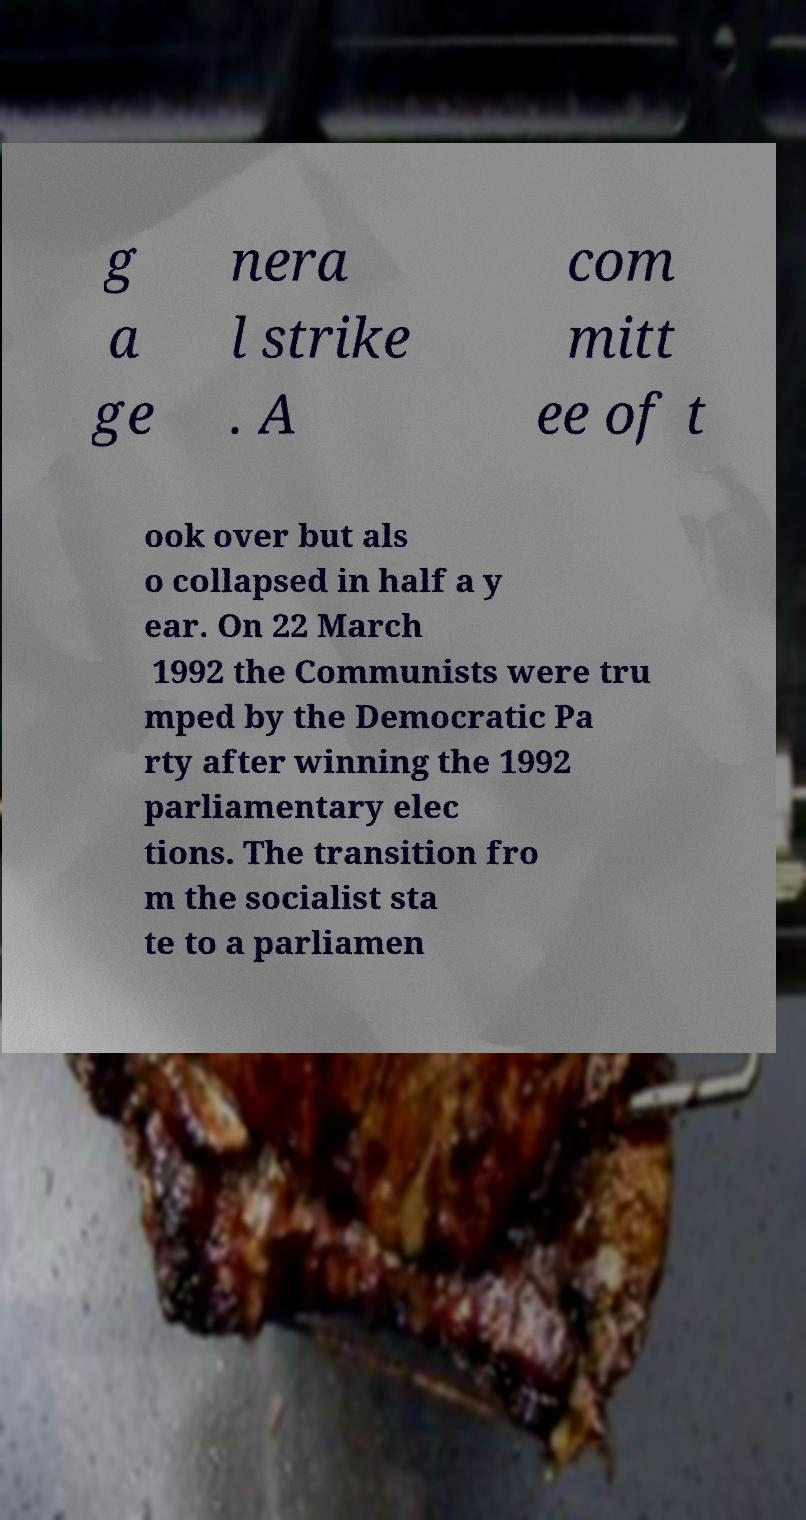Can you read and provide the text displayed in the image?This photo seems to have some interesting text. Can you extract and type it out for me? g a ge nera l strike . A com mitt ee of t ook over but als o collapsed in half a y ear. On 22 March 1992 the Communists were tru mped by the Democratic Pa rty after winning the 1992 parliamentary elec tions. The transition fro m the socialist sta te to a parliamen 